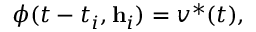<formula> <loc_0><loc_0><loc_500><loc_500>\phi ( t - t _ { i } , h _ { i } ) = v ^ { * } ( t ) ,</formula> 